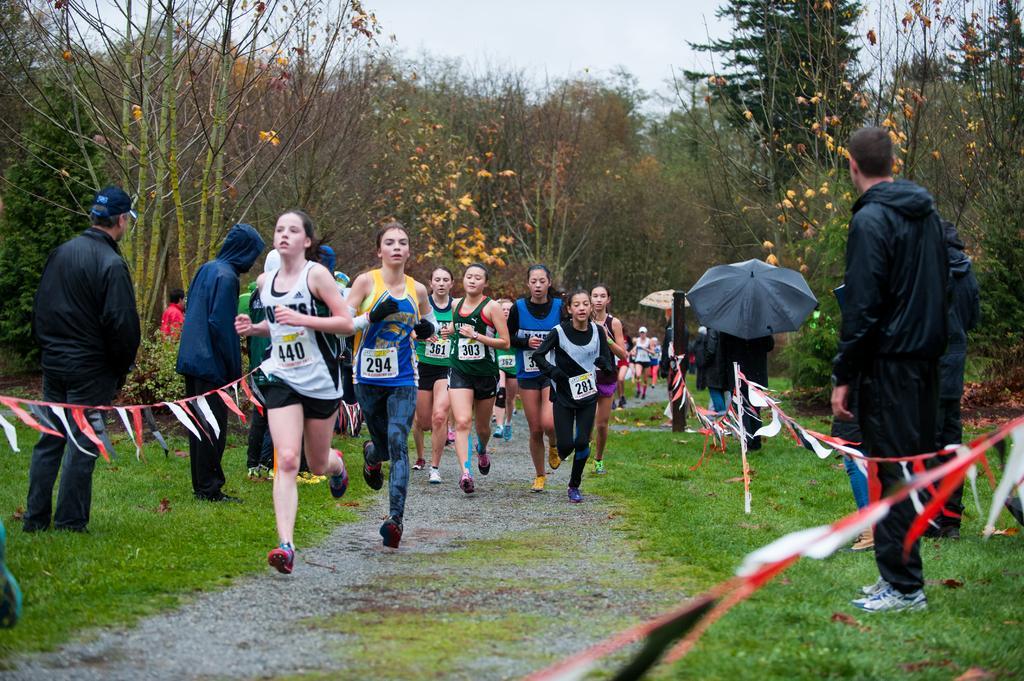In one or two sentences, can you explain what this image depicts? In this image I can see in the middle a group of girls are running. At the top it is the sky. 